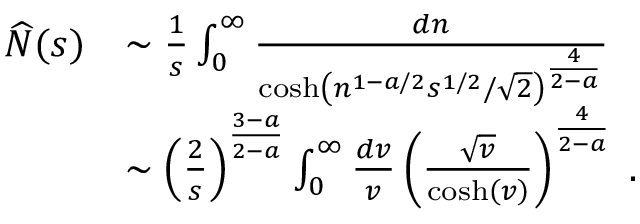<formula> <loc_0><loc_0><loc_500><loc_500>\begin{array} { r l } { \widehat { N } ( s ) } & { \sim \frac { 1 } { s } \int _ { 0 } ^ { \infty } \frac { d n } { \cosh \left ( n ^ { 1 - a / 2 } s ^ { 1 / 2 } / \sqrt { 2 } \right ) ^ { \frac { 4 } { 2 - a } } } } \\ & { \sim \left ( \frac { 2 } { s } \right ) ^ { \frac { 3 - a } { 2 - a } } \int _ { 0 } ^ { \infty } \frac { d v } { v } \left ( \frac { \sqrt { v } } { \cosh \left ( v \right ) } \right ) ^ { \frac { 4 } { 2 - a } } \, . } \end{array}</formula> 